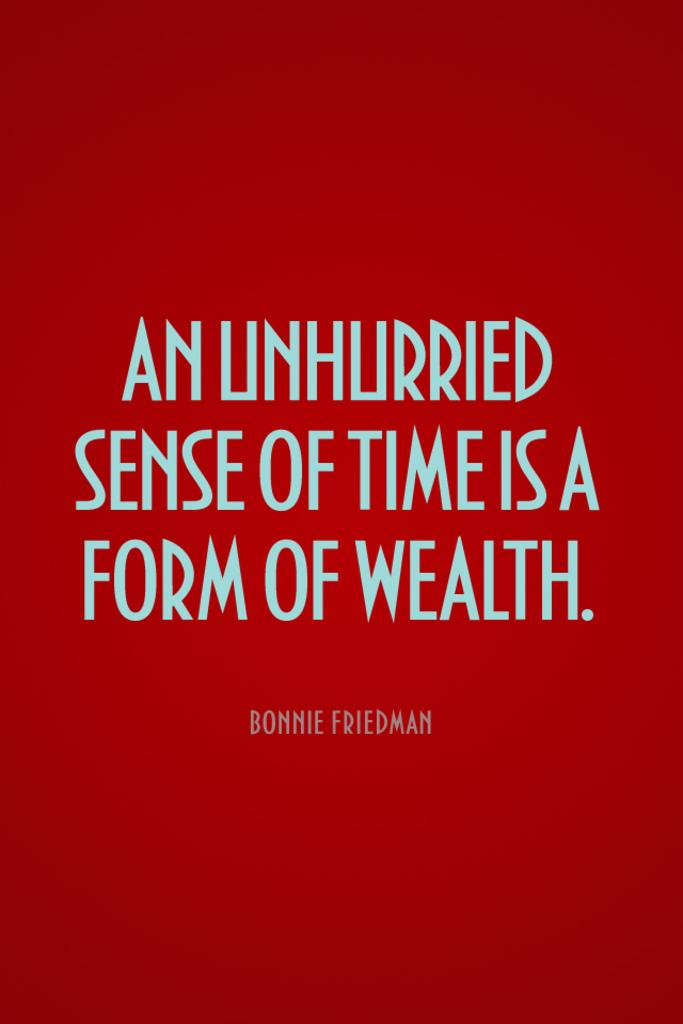<image>
Create a compact narrative representing the image presented. Bonnie Friedman was quoted as saying an unhurried sense of time is a form of wealth 